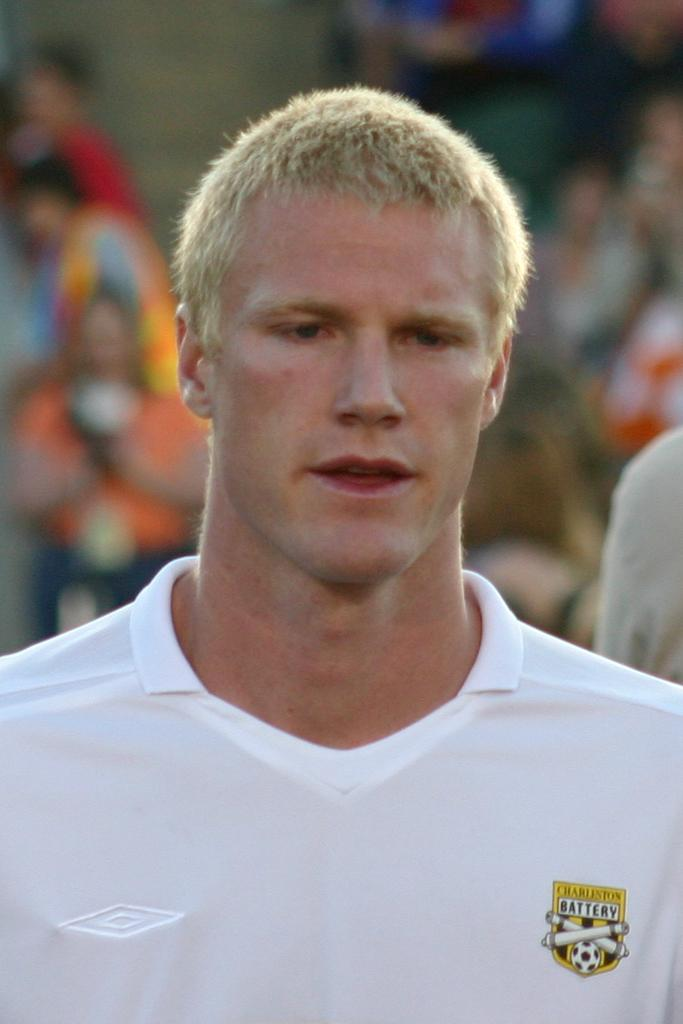Provide a one-sentence caption for the provided image. Man wearing a white shirt that says Charleston Battery. 